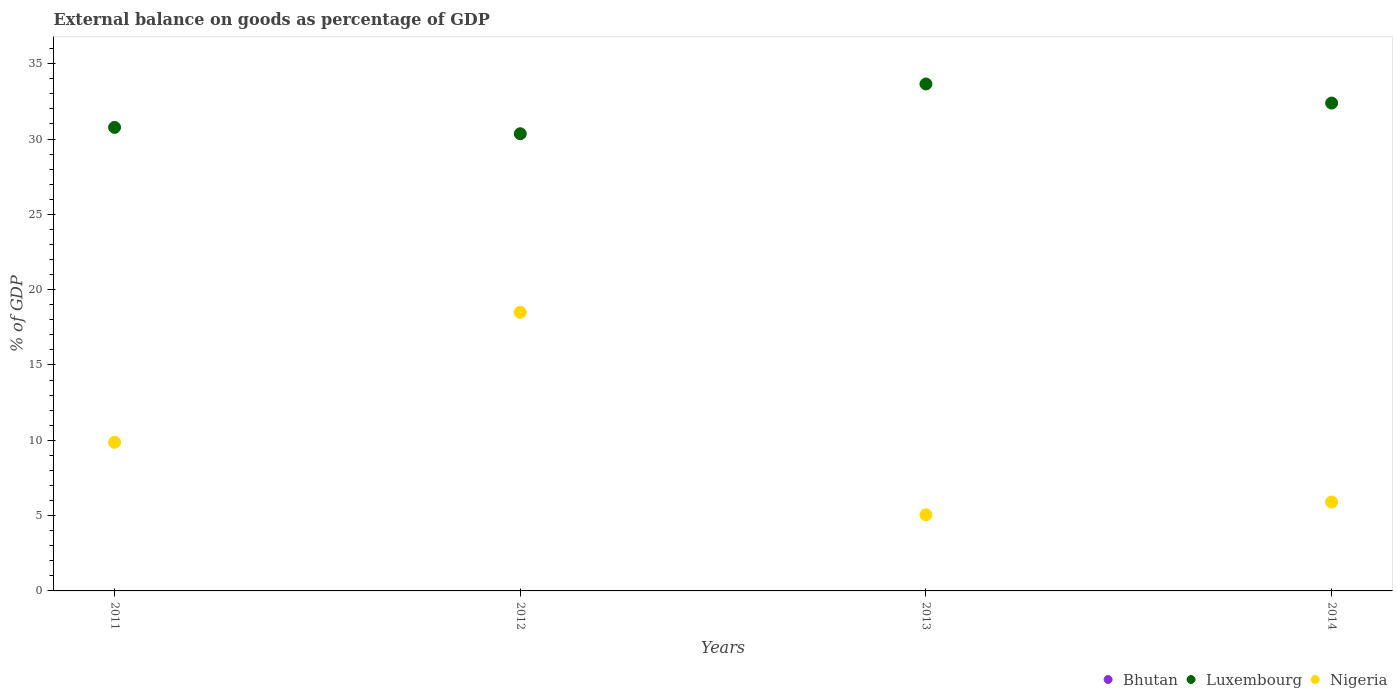How many different coloured dotlines are there?
Ensure brevity in your answer.  2. Is the number of dotlines equal to the number of legend labels?
Keep it short and to the point. No. What is the external balance on goods as percentage of GDP in Luxembourg in 2014?
Make the answer very short. 32.39. Across all years, what is the maximum external balance on goods as percentage of GDP in Luxembourg?
Your response must be concise. 33.66. Across all years, what is the minimum external balance on goods as percentage of GDP in Luxembourg?
Give a very brief answer. 30.35. What is the total external balance on goods as percentage of GDP in Bhutan in the graph?
Make the answer very short. 0. What is the difference between the external balance on goods as percentage of GDP in Nigeria in 2012 and that in 2013?
Offer a terse response. 13.45. What is the difference between the external balance on goods as percentage of GDP in Bhutan in 2011 and the external balance on goods as percentage of GDP in Nigeria in 2013?
Provide a succinct answer. -5.05. What is the average external balance on goods as percentage of GDP in Nigeria per year?
Provide a short and direct response. 9.83. In the year 2011, what is the difference between the external balance on goods as percentage of GDP in Luxembourg and external balance on goods as percentage of GDP in Nigeria?
Offer a terse response. 20.91. In how many years, is the external balance on goods as percentage of GDP in Bhutan greater than 18 %?
Offer a very short reply. 0. What is the ratio of the external balance on goods as percentage of GDP in Luxembourg in 2012 to that in 2014?
Make the answer very short. 0.94. What is the difference between the highest and the second highest external balance on goods as percentage of GDP in Luxembourg?
Make the answer very short. 1.27. What is the difference between the highest and the lowest external balance on goods as percentage of GDP in Luxembourg?
Your answer should be very brief. 3.3. How many dotlines are there?
Ensure brevity in your answer.  2. How many years are there in the graph?
Your answer should be compact. 4. Does the graph contain grids?
Keep it short and to the point. No. Where does the legend appear in the graph?
Make the answer very short. Bottom right. What is the title of the graph?
Your answer should be very brief. External balance on goods as percentage of GDP. What is the label or title of the Y-axis?
Give a very brief answer. % of GDP. What is the % of GDP in Bhutan in 2011?
Give a very brief answer. 0. What is the % of GDP of Luxembourg in 2011?
Provide a short and direct response. 30.77. What is the % of GDP of Nigeria in 2011?
Provide a succinct answer. 9.87. What is the % of GDP of Luxembourg in 2012?
Give a very brief answer. 30.35. What is the % of GDP in Nigeria in 2012?
Ensure brevity in your answer.  18.5. What is the % of GDP of Luxembourg in 2013?
Offer a terse response. 33.66. What is the % of GDP of Nigeria in 2013?
Give a very brief answer. 5.05. What is the % of GDP of Bhutan in 2014?
Provide a short and direct response. 0. What is the % of GDP in Luxembourg in 2014?
Ensure brevity in your answer.  32.39. What is the % of GDP in Nigeria in 2014?
Make the answer very short. 5.9. Across all years, what is the maximum % of GDP in Luxembourg?
Keep it short and to the point. 33.66. Across all years, what is the maximum % of GDP of Nigeria?
Ensure brevity in your answer.  18.5. Across all years, what is the minimum % of GDP of Luxembourg?
Provide a short and direct response. 30.35. Across all years, what is the minimum % of GDP in Nigeria?
Make the answer very short. 5.05. What is the total % of GDP of Luxembourg in the graph?
Your response must be concise. 127.17. What is the total % of GDP in Nigeria in the graph?
Provide a succinct answer. 39.32. What is the difference between the % of GDP of Luxembourg in 2011 and that in 2012?
Your answer should be very brief. 0.42. What is the difference between the % of GDP of Nigeria in 2011 and that in 2012?
Give a very brief answer. -8.63. What is the difference between the % of GDP in Luxembourg in 2011 and that in 2013?
Ensure brevity in your answer.  -2.88. What is the difference between the % of GDP in Nigeria in 2011 and that in 2013?
Offer a terse response. 4.81. What is the difference between the % of GDP of Luxembourg in 2011 and that in 2014?
Make the answer very short. -1.62. What is the difference between the % of GDP of Nigeria in 2011 and that in 2014?
Your response must be concise. 3.96. What is the difference between the % of GDP in Luxembourg in 2012 and that in 2013?
Keep it short and to the point. -3.3. What is the difference between the % of GDP of Nigeria in 2012 and that in 2013?
Keep it short and to the point. 13.45. What is the difference between the % of GDP in Luxembourg in 2012 and that in 2014?
Offer a very short reply. -2.04. What is the difference between the % of GDP of Nigeria in 2012 and that in 2014?
Keep it short and to the point. 12.6. What is the difference between the % of GDP in Luxembourg in 2013 and that in 2014?
Keep it short and to the point. 1.27. What is the difference between the % of GDP of Nigeria in 2013 and that in 2014?
Make the answer very short. -0.85. What is the difference between the % of GDP in Luxembourg in 2011 and the % of GDP in Nigeria in 2012?
Keep it short and to the point. 12.28. What is the difference between the % of GDP of Luxembourg in 2011 and the % of GDP of Nigeria in 2013?
Offer a terse response. 25.72. What is the difference between the % of GDP of Luxembourg in 2011 and the % of GDP of Nigeria in 2014?
Give a very brief answer. 24.87. What is the difference between the % of GDP in Luxembourg in 2012 and the % of GDP in Nigeria in 2013?
Give a very brief answer. 25.3. What is the difference between the % of GDP of Luxembourg in 2012 and the % of GDP of Nigeria in 2014?
Ensure brevity in your answer.  24.45. What is the difference between the % of GDP in Luxembourg in 2013 and the % of GDP in Nigeria in 2014?
Your response must be concise. 27.75. What is the average % of GDP of Bhutan per year?
Provide a short and direct response. 0. What is the average % of GDP in Luxembourg per year?
Make the answer very short. 31.79. What is the average % of GDP of Nigeria per year?
Make the answer very short. 9.83. In the year 2011, what is the difference between the % of GDP of Luxembourg and % of GDP of Nigeria?
Offer a terse response. 20.91. In the year 2012, what is the difference between the % of GDP in Luxembourg and % of GDP in Nigeria?
Provide a short and direct response. 11.86. In the year 2013, what is the difference between the % of GDP of Luxembourg and % of GDP of Nigeria?
Give a very brief answer. 28.6. In the year 2014, what is the difference between the % of GDP of Luxembourg and % of GDP of Nigeria?
Provide a succinct answer. 26.49. What is the ratio of the % of GDP in Luxembourg in 2011 to that in 2012?
Give a very brief answer. 1.01. What is the ratio of the % of GDP in Nigeria in 2011 to that in 2012?
Offer a very short reply. 0.53. What is the ratio of the % of GDP in Luxembourg in 2011 to that in 2013?
Offer a terse response. 0.91. What is the ratio of the % of GDP of Nigeria in 2011 to that in 2013?
Make the answer very short. 1.95. What is the ratio of the % of GDP of Luxembourg in 2011 to that in 2014?
Your answer should be compact. 0.95. What is the ratio of the % of GDP of Nigeria in 2011 to that in 2014?
Your answer should be very brief. 1.67. What is the ratio of the % of GDP of Luxembourg in 2012 to that in 2013?
Make the answer very short. 0.9. What is the ratio of the % of GDP of Nigeria in 2012 to that in 2013?
Keep it short and to the point. 3.66. What is the ratio of the % of GDP in Luxembourg in 2012 to that in 2014?
Make the answer very short. 0.94. What is the ratio of the % of GDP in Nigeria in 2012 to that in 2014?
Offer a terse response. 3.13. What is the ratio of the % of GDP in Luxembourg in 2013 to that in 2014?
Offer a terse response. 1.04. What is the ratio of the % of GDP of Nigeria in 2013 to that in 2014?
Your answer should be very brief. 0.86. What is the difference between the highest and the second highest % of GDP in Luxembourg?
Make the answer very short. 1.27. What is the difference between the highest and the second highest % of GDP of Nigeria?
Make the answer very short. 8.63. What is the difference between the highest and the lowest % of GDP of Luxembourg?
Your response must be concise. 3.3. What is the difference between the highest and the lowest % of GDP of Nigeria?
Provide a succinct answer. 13.45. 